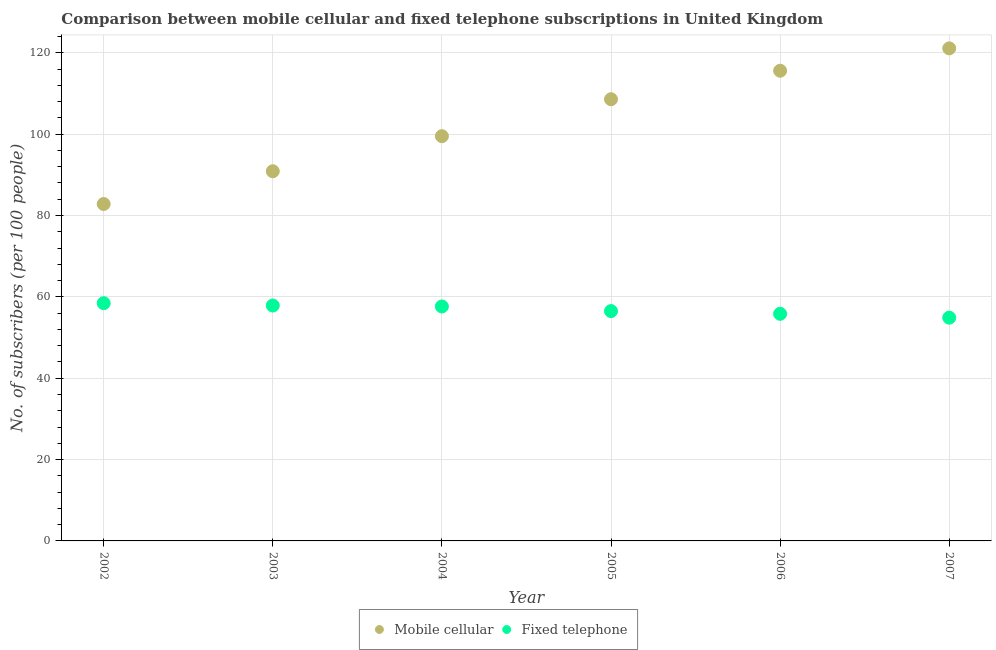What is the number of mobile cellular subscribers in 2004?
Offer a very short reply. 99.51. Across all years, what is the maximum number of mobile cellular subscribers?
Make the answer very short. 121.1. Across all years, what is the minimum number of fixed telephone subscribers?
Your answer should be compact. 54.88. In which year was the number of fixed telephone subscribers minimum?
Your answer should be compact. 2007. What is the total number of mobile cellular subscribers in the graph?
Give a very brief answer. 618.52. What is the difference between the number of mobile cellular subscribers in 2002 and that in 2003?
Offer a very short reply. -8.05. What is the difference between the number of fixed telephone subscribers in 2007 and the number of mobile cellular subscribers in 2006?
Ensure brevity in your answer.  -60.72. What is the average number of fixed telephone subscribers per year?
Keep it short and to the point. 56.87. In the year 2005, what is the difference between the number of mobile cellular subscribers and number of fixed telephone subscribers?
Your answer should be very brief. 52.09. In how many years, is the number of fixed telephone subscribers greater than 40?
Your answer should be compact. 6. What is the ratio of the number of fixed telephone subscribers in 2003 to that in 2005?
Provide a succinct answer. 1.02. What is the difference between the highest and the second highest number of fixed telephone subscribers?
Your answer should be compact. 0.57. What is the difference between the highest and the lowest number of fixed telephone subscribers?
Your answer should be compact. 3.57. Is the sum of the number of fixed telephone subscribers in 2004 and 2007 greater than the maximum number of mobile cellular subscribers across all years?
Your answer should be compact. No. Is the number of mobile cellular subscribers strictly less than the number of fixed telephone subscribers over the years?
Give a very brief answer. No. How many dotlines are there?
Keep it short and to the point. 2. Are the values on the major ticks of Y-axis written in scientific E-notation?
Your response must be concise. No. Does the graph contain any zero values?
Your response must be concise. No. Does the graph contain grids?
Offer a terse response. Yes. Where does the legend appear in the graph?
Make the answer very short. Bottom center. How many legend labels are there?
Offer a terse response. 2. How are the legend labels stacked?
Keep it short and to the point. Horizontal. What is the title of the graph?
Your answer should be very brief. Comparison between mobile cellular and fixed telephone subscriptions in United Kingdom. What is the label or title of the Y-axis?
Your response must be concise. No. of subscribers (per 100 people). What is the No. of subscribers (per 100 people) of Mobile cellular in 2002?
Provide a succinct answer. 82.83. What is the No. of subscribers (per 100 people) of Fixed telephone in 2002?
Keep it short and to the point. 58.45. What is the No. of subscribers (per 100 people) of Mobile cellular in 2003?
Your answer should be very brief. 90.88. What is the No. of subscribers (per 100 people) in Fixed telephone in 2003?
Keep it short and to the point. 57.88. What is the No. of subscribers (per 100 people) in Mobile cellular in 2004?
Your answer should be compact. 99.51. What is the No. of subscribers (per 100 people) in Fixed telephone in 2004?
Give a very brief answer. 57.64. What is the No. of subscribers (per 100 people) in Mobile cellular in 2005?
Provide a short and direct response. 108.59. What is the No. of subscribers (per 100 people) of Fixed telephone in 2005?
Provide a succinct answer. 56.51. What is the No. of subscribers (per 100 people) in Mobile cellular in 2006?
Your answer should be compact. 115.6. What is the No. of subscribers (per 100 people) of Fixed telephone in 2006?
Provide a succinct answer. 55.84. What is the No. of subscribers (per 100 people) of Mobile cellular in 2007?
Your response must be concise. 121.1. What is the No. of subscribers (per 100 people) of Fixed telephone in 2007?
Provide a short and direct response. 54.88. Across all years, what is the maximum No. of subscribers (per 100 people) in Mobile cellular?
Your answer should be very brief. 121.1. Across all years, what is the maximum No. of subscribers (per 100 people) of Fixed telephone?
Make the answer very short. 58.45. Across all years, what is the minimum No. of subscribers (per 100 people) of Mobile cellular?
Offer a terse response. 82.83. Across all years, what is the minimum No. of subscribers (per 100 people) of Fixed telephone?
Give a very brief answer. 54.88. What is the total No. of subscribers (per 100 people) of Mobile cellular in the graph?
Provide a short and direct response. 618.52. What is the total No. of subscribers (per 100 people) of Fixed telephone in the graph?
Ensure brevity in your answer.  341.19. What is the difference between the No. of subscribers (per 100 people) of Mobile cellular in 2002 and that in 2003?
Provide a succinct answer. -8.05. What is the difference between the No. of subscribers (per 100 people) of Fixed telephone in 2002 and that in 2003?
Offer a very short reply. 0.57. What is the difference between the No. of subscribers (per 100 people) in Mobile cellular in 2002 and that in 2004?
Give a very brief answer. -16.68. What is the difference between the No. of subscribers (per 100 people) of Fixed telephone in 2002 and that in 2004?
Ensure brevity in your answer.  0.81. What is the difference between the No. of subscribers (per 100 people) of Mobile cellular in 2002 and that in 2005?
Provide a short and direct response. -25.76. What is the difference between the No. of subscribers (per 100 people) of Fixed telephone in 2002 and that in 2005?
Your response must be concise. 1.94. What is the difference between the No. of subscribers (per 100 people) in Mobile cellular in 2002 and that in 2006?
Your answer should be very brief. -32.77. What is the difference between the No. of subscribers (per 100 people) in Fixed telephone in 2002 and that in 2006?
Your answer should be very brief. 2.61. What is the difference between the No. of subscribers (per 100 people) in Mobile cellular in 2002 and that in 2007?
Offer a terse response. -38.27. What is the difference between the No. of subscribers (per 100 people) in Fixed telephone in 2002 and that in 2007?
Your response must be concise. 3.57. What is the difference between the No. of subscribers (per 100 people) in Mobile cellular in 2003 and that in 2004?
Your answer should be very brief. -8.62. What is the difference between the No. of subscribers (per 100 people) in Fixed telephone in 2003 and that in 2004?
Your answer should be very brief. 0.23. What is the difference between the No. of subscribers (per 100 people) in Mobile cellular in 2003 and that in 2005?
Your answer should be very brief. -17.71. What is the difference between the No. of subscribers (per 100 people) in Fixed telephone in 2003 and that in 2005?
Keep it short and to the point. 1.37. What is the difference between the No. of subscribers (per 100 people) of Mobile cellular in 2003 and that in 2006?
Your answer should be compact. -24.72. What is the difference between the No. of subscribers (per 100 people) in Fixed telephone in 2003 and that in 2006?
Provide a short and direct response. 2.04. What is the difference between the No. of subscribers (per 100 people) in Mobile cellular in 2003 and that in 2007?
Offer a terse response. -30.22. What is the difference between the No. of subscribers (per 100 people) in Fixed telephone in 2003 and that in 2007?
Your answer should be compact. 2.99. What is the difference between the No. of subscribers (per 100 people) of Mobile cellular in 2004 and that in 2005?
Your answer should be very brief. -9.09. What is the difference between the No. of subscribers (per 100 people) of Fixed telephone in 2004 and that in 2005?
Offer a very short reply. 1.14. What is the difference between the No. of subscribers (per 100 people) in Mobile cellular in 2004 and that in 2006?
Your answer should be compact. -16.09. What is the difference between the No. of subscribers (per 100 people) of Fixed telephone in 2004 and that in 2006?
Your response must be concise. 1.81. What is the difference between the No. of subscribers (per 100 people) of Mobile cellular in 2004 and that in 2007?
Keep it short and to the point. -21.6. What is the difference between the No. of subscribers (per 100 people) of Fixed telephone in 2004 and that in 2007?
Offer a terse response. 2.76. What is the difference between the No. of subscribers (per 100 people) in Mobile cellular in 2005 and that in 2006?
Offer a very short reply. -7.01. What is the difference between the No. of subscribers (per 100 people) of Fixed telephone in 2005 and that in 2006?
Make the answer very short. 0.67. What is the difference between the No. of subscribers (per 100 people) in Mobile cellular in 2005 and that in 2007?
Your answer should be very brief. -12.51. What is the difference between the No. of subscribers (per 100 people) in Fixed telephone in 2005 and that in 2007?
Offer a very short reply. 1.62. What is the difference between the No. of subscribers (per 100 people) of Mobile cellular in 2006 and that in 2007?
Make the answer very short. -5.5. What is the difference between the No. of subscribers (per 100 people) of Fixed telephone in 2006 and that in 2007?
Keep it short and to the point. 0.95. What is the difference between the No. of subscribers (per 100 people) of Mobile cellular in 2002 and the No. of subscribers (per 100 people) of Fixed telephone in 2003?
Keep it short and to the point. 24.96. What is the difference between the No. of subscribers (per 100 people) of Mobile cellular in 2002 and the No. of subscribers (per 100 people) of Fixed telephone in 2004?
Keep it short and to the point. 25.19. What is the difference between the No. of subscribers (per 100 people) of Mobile cellular in 2002 and the No. of subscribers (per 100 people) of Fixed telephone in 2005?
Your answer should be compact. 26.32. What is the difference between the No. of subscribers (per 100 people) of Mobile cellular in 2002 and the No. of subscribers (per 100 people) of Fixed telephone in 2006?
Your answer should be very brief. 26.99. What is the difference between the No. of subscribers (per 100 people) in Mobile cellular in 2002 and the No. of subscribers (per 100 people) in Fixed telephone in 2007?
Make the answer very short. 27.95. What is the difference between the No. of subscribers (per 100 people) in Mobile cellular in 2003 and the No. of subscribers (per 100 people) in Fixed telephone in 2004?
Your answer should be very brief. 33.24. What is the difference between the No. of subscribers (per 100 people) in Mobile cellular in 2003 and the No. of subscribers (per 100 people) in Fixed telephone in 2005?
Give a very brief answer. 34.38. What is the difference between the No. of subscribers (per 100 people) of Mobile cellular in 2003 and the No. of subscribers (per 100 people) of Fixed telephone in 2006?
Your response must be concise. 35.05. What is the difference between the No. of subscribers (per 100 people) in Mobile cellular in 2003 and the No. of subscribers (per 100 people) in Fixed telephone in 2007?
Your response must be concise. 36. What is the difference between the No. of subscribers (per 100 people) in Mobile cellular in 2004 and the No. of subscribers (per 100 people) in Fixed telephone in 2005?
Provide a short and direct response. 43. What is the difference between the No. of subscribers (per 100 people) in Mobile cellular in 2004 and the No. of subscribers (per 100 people) in Fixed telephone in 2006?
Your response must be concise. 43.67. What is the difference between the No. of subscribers (per 100 people) in Mobile cellular in 2004 and the No. of subscribers (per 100 people) in Fixed telephone in 2007?
Keep it short and to the point. 44.62. What is the difference between the No. of subscribers (per 100 people) in Mobile cellular in 2005 and the No. of subscribers (per 100 people) in Fixed telephone in 2006?
Give a very brief answer. 52.76. What is the difference between the No. of subscribers (per 100 people) in Mobile cellular in 2005 and the No. of subscribers (per 100 people) in Fixed telephone in 2007?
Give a very brief answer. 53.71. What is the difference between the No. of subscribers (per 100 people) in Mobile cellular in 2006 and the No. of subscribers (per 100 people) in Fixed telephone in 2007?
Your answer should be very brief. 60.72. What is the average No. of subscribers (per 100 people) of Mobile cellular per year?
Ensure brevity in your answer.  103.09. What is the average No. of subscribers (per 100 people) of Fixed telephone per year?
Your response must be concise. 56.87. In the year 2002, what is the difference between the No. of subscribers (per 100 people) in Mobile cellular and No. of subscribers (per 100 people) in Fixed telephone?
Your answer should be very brief. 24.38. In the year 2003, what is the difference between the No. of subscribers (per 100 people) of Mobile cellular and No. of subscribers (per 100 people) of Fixed telephone?
Your answer should be compact. 33.01. In the year 2004, what is the difference between the No. of subscribers (per 100 people) of Mobile cellular and No. of subscribers (per 100 people) of Fixed telephone?
Offer a terse response. 41.86. In the year 2005, what is the difference between the No. of subscribers (per 100 people) in Mobile cellular and No. of subscribers (per 100 people) in Fixed telephone?
Give a very brief answer. 52.09. In the year 2006, what is the difference between the No. of subscribers (per 100 people) in Mobile cellular and No. of subscribers (per 100 people) in Fixed telephone?
Provide a succinct answer. 59.76. In the year 2007, what is the difference between the No. of subscribers (per 100 people) in Mobile cellular and No. of subscribers (per 100 people) in Fixed telephone?
Keep it short and to the point. 66.22. What is the ratio of the No. of subscribers (per 100 people) in Mobile cellular in 2002 to that in 2003?
Your answer should be very brief. 0.91. What is the ratio of the No. of subscribers (per 100 people) in Fixed telephone in 2002 to that in 2003?
Make the answer very short. 1.01. What is the ratio of the No. of subscribers (per 100 people) in Mobile cellular in 2002 to that in 2004?
Offer a very short reply. 0.83. What is the ratio of the No. of subscribers (per 100 people) of Fixed telephone in 2002 to that in 2004?
Your response must be concise. 1.01. What is the ratio of the No. of subscribers (per 100 people) of Mobile cellular in 2002 to that in 2005?
Provide a succinct answer. 0.76. What is the ratio of the No. of subscribers (per 100 people) in Fixed telephone in 2002 to that in 2005?
Your response must be concise. 1.03. What is the ratio of the No. of subscribers (per 100 people) in Mobile cellular in 2002 to that in 2006?
Your answer should be compact. 0.72. What is the ratio of the No. of subscribers (per 100 people) of Fixed telephone in 2002 to that in 2006?
Your answer should be very brief. 1.05. What is the ratio of the No. of subscribers (per 100 people) of Mobile cellular in 2002 to that in 2007?
Offer a very short reply. 0.68. What is the ratio of the No. of subscribers (per 100 people) in Fixed telephone in 2002 to that in 2007?
Ensure brevity in your answer.  1.06. What is the ratio of the No. of subscribers (per 100 people) in Mobile cellular in 2003 to that in 2004?
Keep it short and to the point. 0.91. What is the ratio of the No. of subscribers (per 100 people) of Fixed telephone in 2003 to that in 2004?
Offer a very short reply. 1. What is the ratio of the No. of subscribers (per 100 people) in Mobile cellular in 2003 to that in 2005?
Offer a terse response. 0.84. What is the ratio of the No. of subscribers (per 100 people) in Fixed telephone in 2003 to that in 2005?
Offer a very short reply. 1.02. What is the ratio of the No. of subscribers (per 100 people) in Mobile cellular in 2003 to that in 2006?
Your answer should be compact. 0.79. What is the ratio of the No. of subscribers (per 100 people) of Fixed telephone in 2003 to that in 2006?
Ensure brevity in your answer.  1.04. What is the ratio of the No. of subscribers (per 100 people) of Mobile cellular in 2003 to that in 2007?
Offer a terse response. 0.75. What is the ratio of the No. of subscribers (per 100 people) in Fixed telephone in 2003 to that in 2007?
Offer a very short reply. 1.05. What is the ratio of the No. of subscribers (per 100 people) in Mobile cellular in 2004 to that in 2005?
Your response must be concise. 0.92. What is the ratio of the No. of subscribers (per 100 people) in Fixed telephone in 2004 to that in 2005?
Provide a short and direct response. 1.02. What is the ratio of the No. of subscribers (per 100 people) in Mobile cellular in 2004 to that in 2006?
Ensure brevity in your answer.  0.86. What is the ratio of the No. of subscribers (per 100 people) in Fixed telephone in 2004 to that in 2006?
Offer a terse response. 1.03. What is the ratio of the No. of subscribers (per 100 people) in Mobile cellular in 2004 to that in 2007?
Your response must be concise. 0.82. What is the ratio of the No. of subscribers (per 100 people) of Fixed telephone in 2004 to that in 2007?
Keep it short and to the point. 1.05. What is the ratio of the No. of subscribers (per 100 people) in Mobile cellular in 2005 to that in 2006?
Your answer should be compact. 0.94. What is the ratio of the No. of subscribers (per 100 people) in Mobile cellular in 2005 to that in 2007?
Provide a short and direct response. 0.9. What is the ratio of the No. of subscribers (per 100 people) in Fixed telephone in 2005 to that in 2007?
Your answer should be very brief. 1.03. What is the ratio of the No. of subscribers (per 100 people) in Mobile cellular in 2006 to that in 2007?
Offer a very short reply. 0.95. What is the ratio of the No. of subscribers (per 100 people) of Fixed telephone in 2006 to that in 2007?
Provide a short and direct response. 1.02. What is the difference between the highest and the second highest No. of subscribers (per 100 people) of Mobile cellular?
Provide a short and direct response. 5.5. What is the difference between the highest and the second highest No. of subscribers (per 100 people) of Fixed telephone?
Give a very brief answer. 0.57. What is the difference between the highest and the lowest No. of subscribers (per 100 people) in Mobile cellular?
Offer a very short reply. 38.27. What is the difference between the highest and the lowest No. of subscribers (per 100 people) in Fixed telephone?
Offer a very short reply. 3.57. 